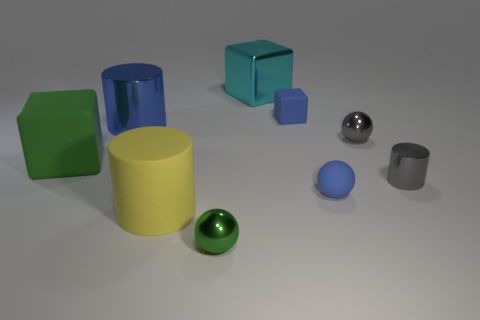Add 1 brown cubes. How many objects exist? 10 Subtract all cylinders. How many objects are left? 6 Add 9 small gray metallic cylinders. How many small gray metallic cylinders exist? 10 Subtract 1 cyan cubes. How many objects are left? 8 Subtract all large green matte cubes. Subtract all small gray things. How many objects are left? 6 Add 4 large blue cylinders. How many large blue cylinders are left? 5 